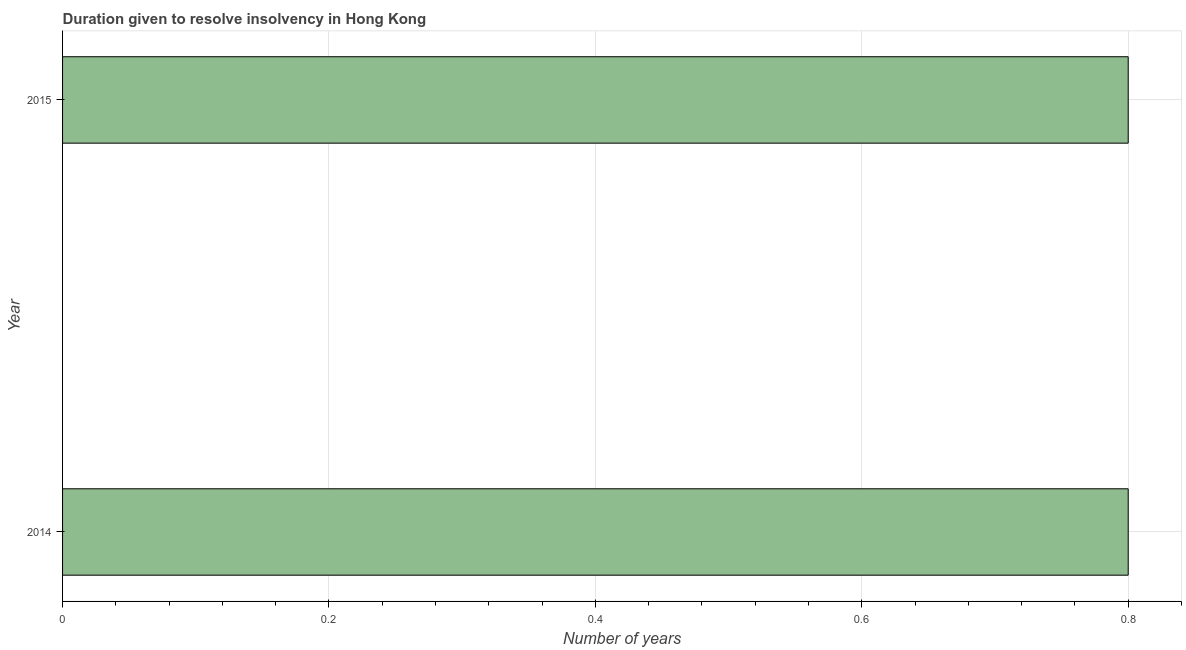Does the graph contain grids?
Give a very brief answer. Yes. What is the title of the graph?
Give a very brief answer. Duration given to resolve insolvency in Hong Kong. What is the label or title of the X-axis?
Your answer should be very brief. Number of years. What is the label or title of the Y-axis?
Make the answer very short. Year. Across all years, what is the maximum number of years to resolve insolvency?
Provide a succinct answer. 0.8. In which year was the number of years to resolve insolvency maximum?
Offer a terse response. 2014. What is the sum of the number of years to resolve insolvency?
Provide a succinct answer. 1.6. What is the average number of years to resolve insolvency per year?
Keep it short and to the point. 0.8. What is the median number of years to resolve insolvency?
Your answer should be very brief. 0.8. In how many years, is the number of years to resolve insolvency greater than 0.28 ?
Provide a succinct answer. 2. What is the ratio of the number of years to resolve insolvency in 2014 to that in 2015?
Provide a succinct answer. 1. Is the number of years to resolve insolvency in 2014 less than that in 2015?
Offer a terse response. No. Are all the bars in the graph horizontal?
Make the answer very short. Yes. How many years are there in the graph?
Your answer should be compact. 2. What is the difference between two consecutive major ticks on the X-axis?
Offer a very short reply. 0.2. Are the values on the major ticks of X-axis written in scientific E-notation?
Your answer should be very brief. No. What is the Number of years in 2014?
Provide a short and direct response. 0.8. What is the ratio of the Number of years in 2014 to that in 2015?
Your answer should be compact. 1. 